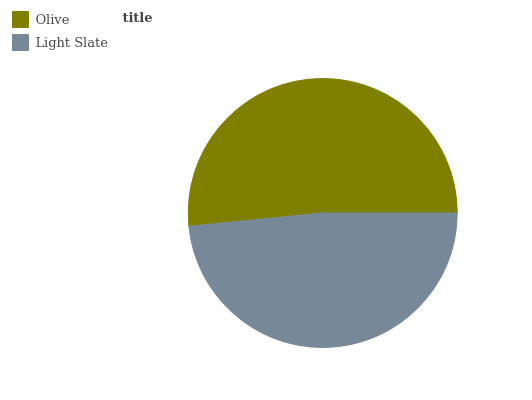Is Light Slate the minimum?
Answer yes or no. Yes. Is Olive the maximum?
Answer yes or no. Yes. Is Light Slate the maximum?
Answer yes or no. No. Is Olive greater than Light Slate?
Answer yes or no. Yes. Is Light Slate less than Olive?
Answer yes or no. Yes. Is Light Slate greater than Olive?
Answer yes or no. No. Is Olive less than Light Slate?
Answer yes or no. No. Is Olive the high median?
Answer yes or no. Yes. Is Light Slate the low median?
Answer yes or no. Yes. Is Light Slate the high median?
Answer yes or no. No. Is Olive the low median?
Answer yes or no. No. 